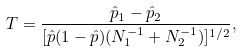Convert formula to latex. <formula><loc_0><loc_0><loc_500><loc_500>T = \frac { \hat { p } _ { 1 } - \hat { p } _ { 2 } } { [ \hat { p } ( 1 - \hat { p } ) ( N _ { 1 } ^ { - 1 } + N _ { 2 } ^ { - 1 } ) ] ^ { 1 / 2 } } ,</formula> 